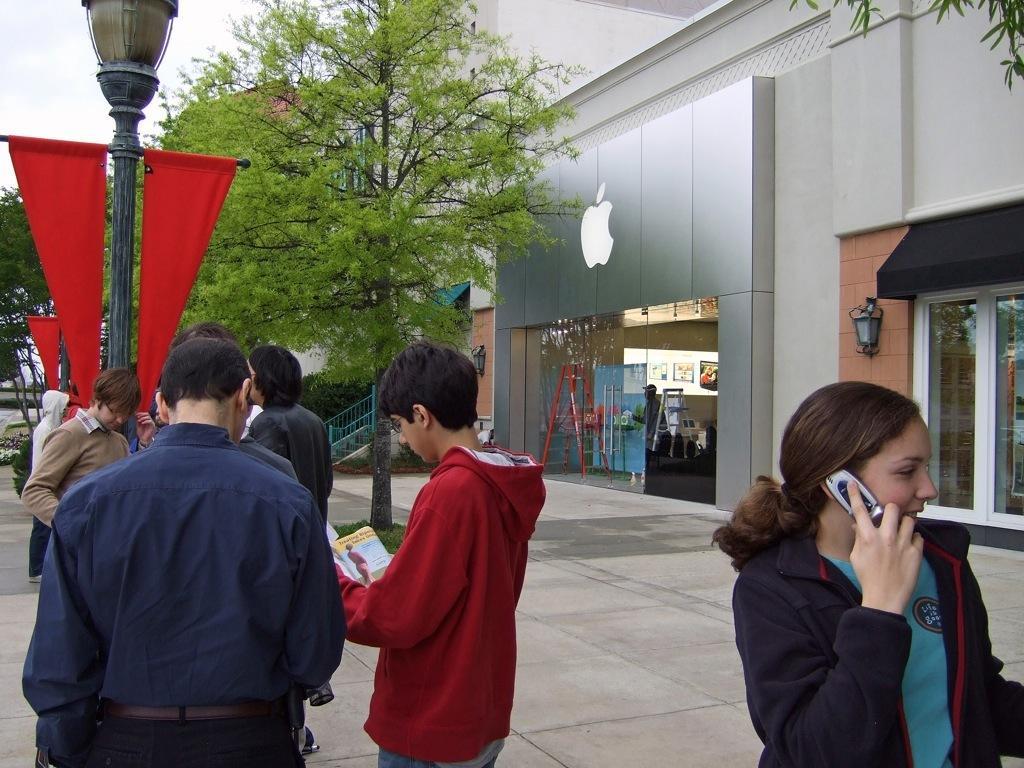Describe this image in one or two sentences. In this image on the street there are few people. In the right a lady is holding a phone she is talking something. In the background there are stores, trees, lamps, flags. 